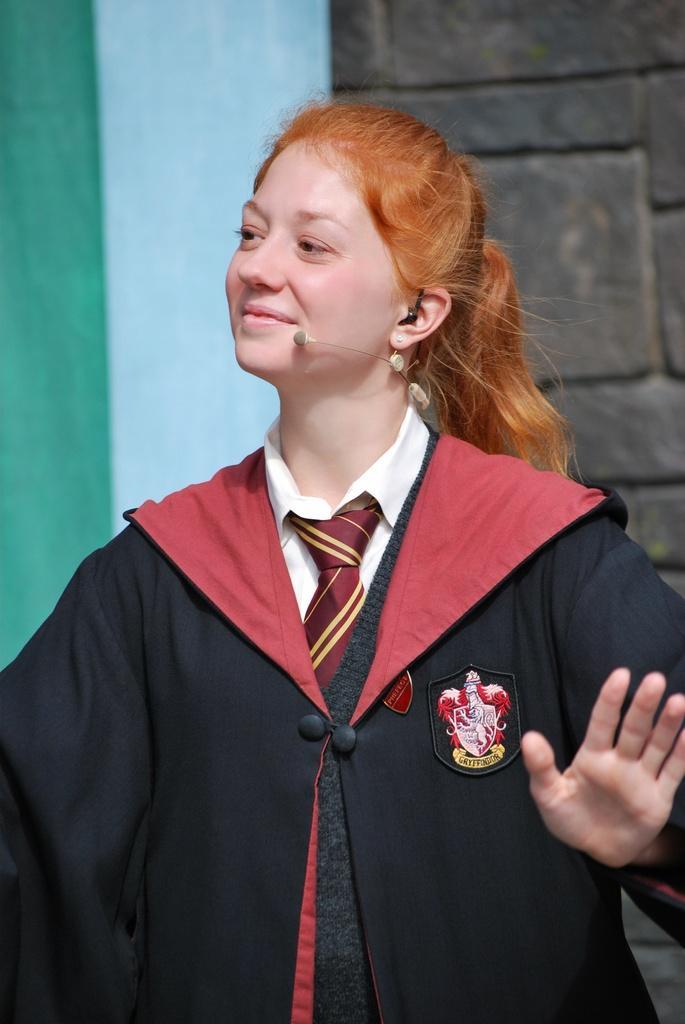Could you give a brief overview of what you see in this image? Here I can see a woman wearing a black color coat, standing and smiling by looking at the left side. In the background there is a cloth which is in green and white colors and also there is a wall. 